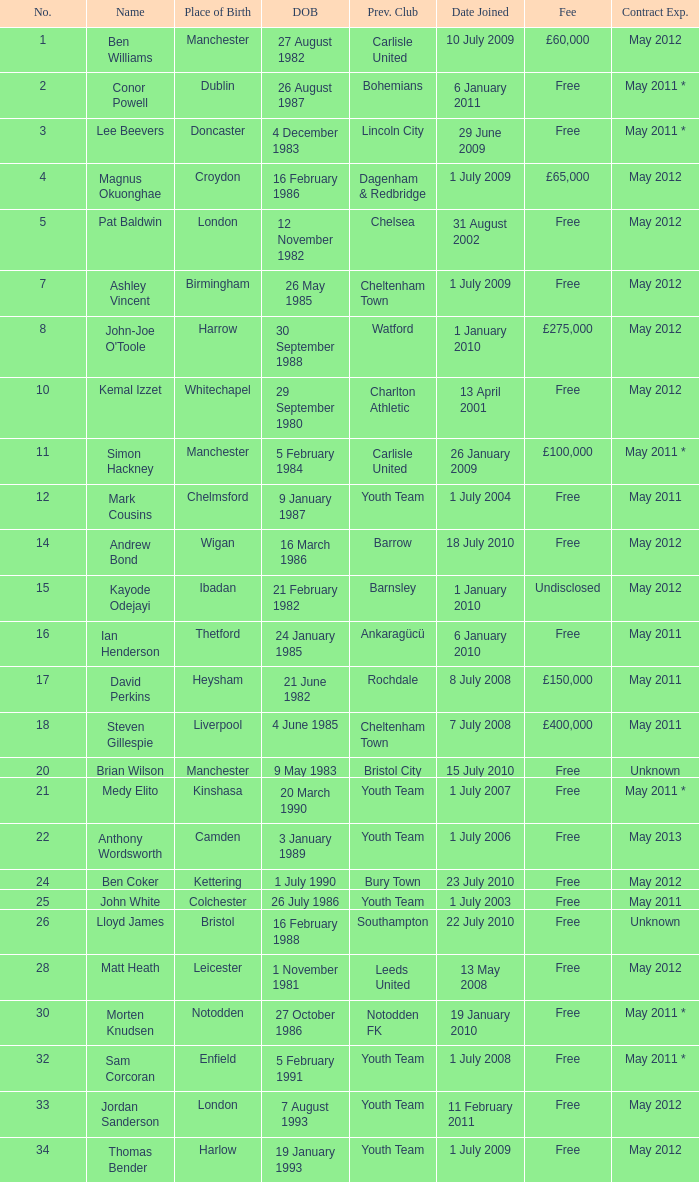How many date of birts are if the previous club is chelsea 1.0. 